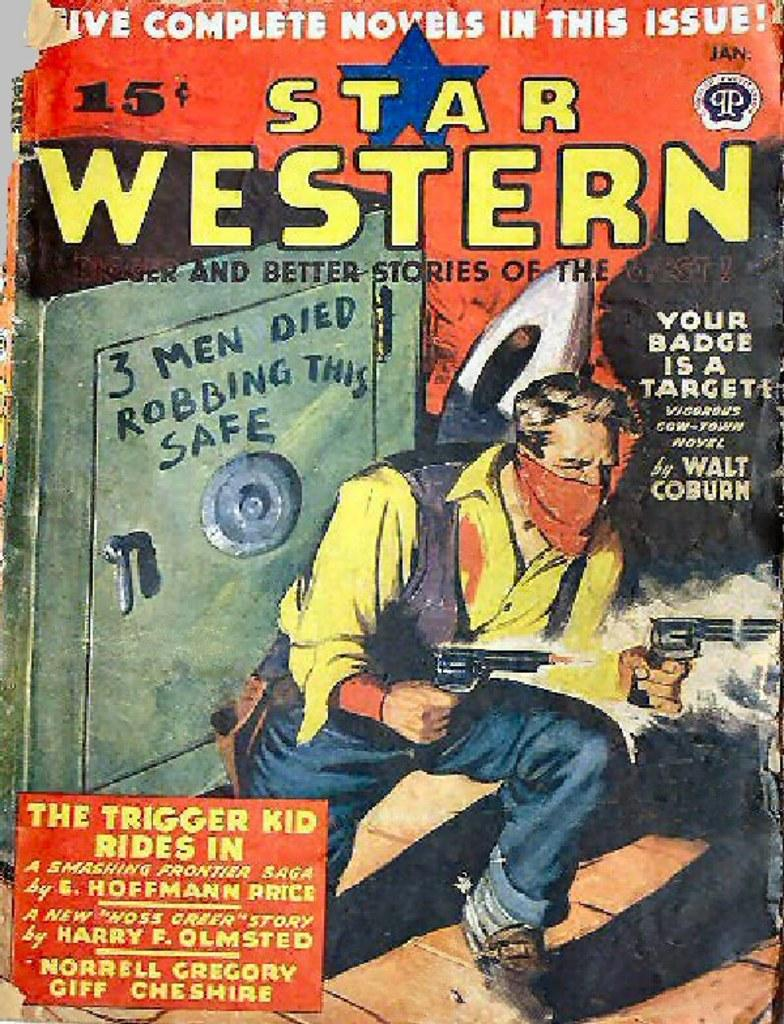Provide a one-sentence caption for the provided image. The cover of a Star Western book features a man holding a gun. 